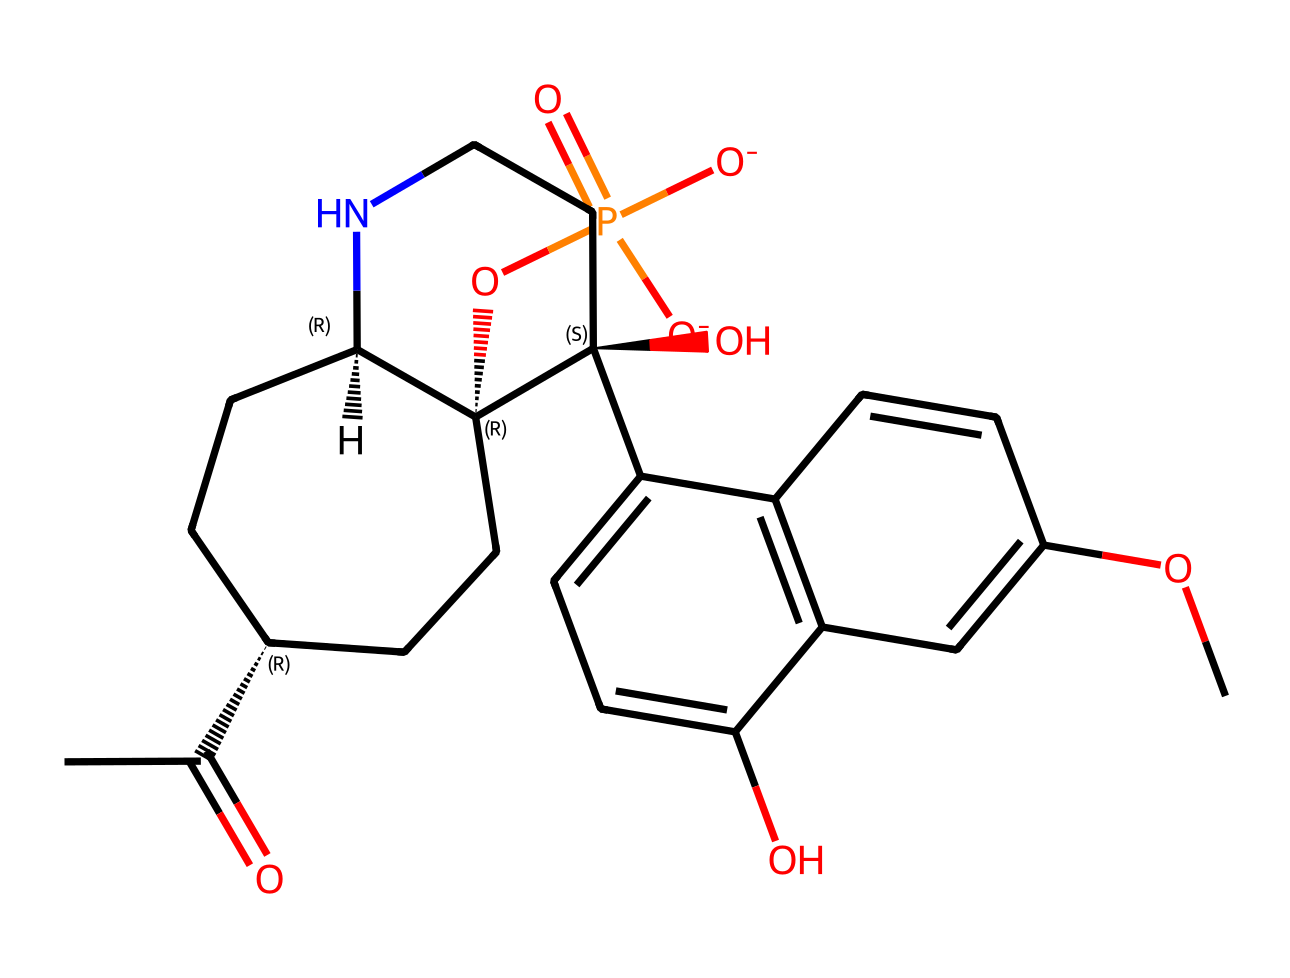What is the functional group of this compound? This compound contains a ketone functional group, which is indicated by the C(=O) portion at the beginning of the SMILES.
Answer: ketone How many rings are present in the chemical structure? Upon analyzing the structure, it can be seen that there are two cycloalkane rings formed within the structure, specifically two six-membered rings.
Answer: two What type of drug is represented by this chemical? Since this compound interacts primarily with opioid receptors to counteract overdose effects, it is classified as an opioid antagonist.
Answer: opioid antagonist How many hydroxyl (OH) groups are present? By inspecting the structure, there are two distinct locations with OH groups, indicating that there are two hydroxyl functional groups present.
Answer: two What is the overall charge of the molecule? The phosphate group in this compound contributes a negative charge, and since there are two negatively charged oxygen atoms in that group without any compensating positive charges elsewhere, the overall charge is -2.
Answer: -2 On which receptor does this drug primarily act? The primary action of this drug is on the mu-opioid receptor, which it blocks to reverse opioid overdose symptoms.
Answer: mu-opioid receptor 